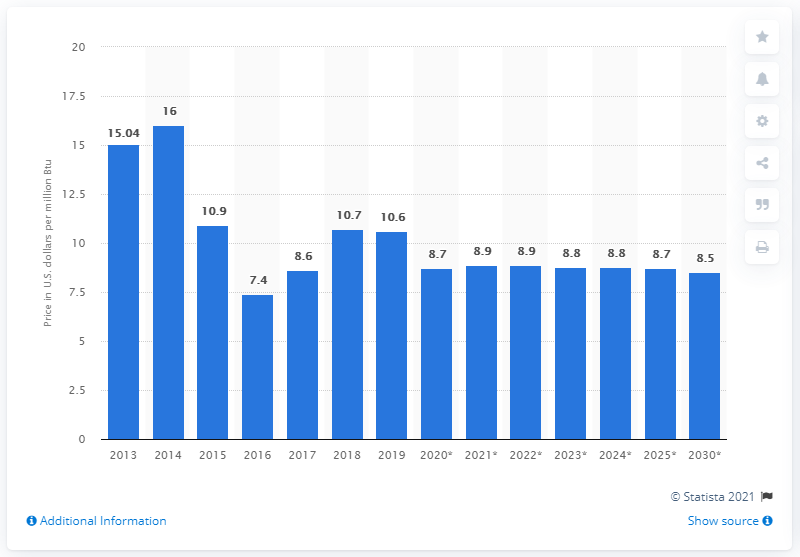List a handful of essential elements in this visual. In 2019, the cost of liquified natural gas per million British thermal units in Japan was 10.6.. 